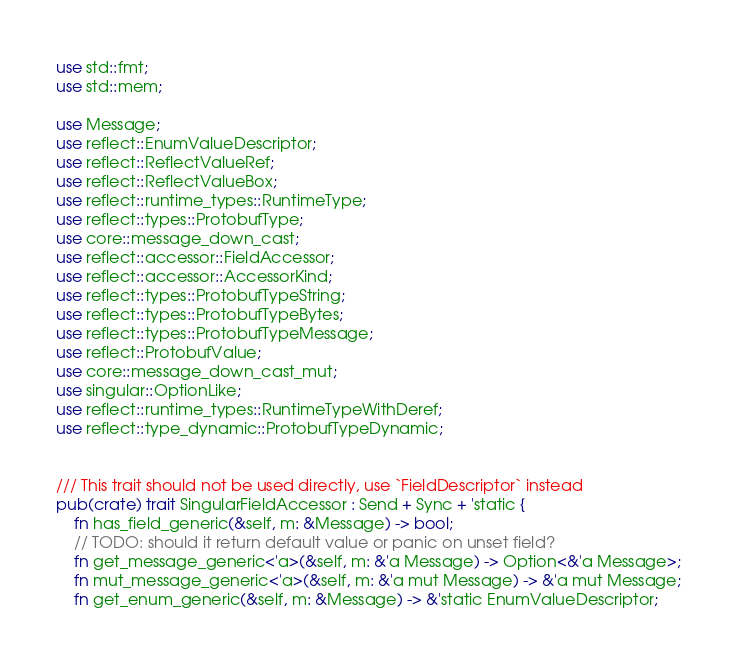<code> <loc_0><loc_0><loc_500><loc_500><_Rust_>use std::fmt;
use std::mem;

use Message;
use reflect::EnumValueDescriptor;
use reflect::ReflectValueRef;
use reflect::ReflectValueBox;
use reflect::runtime_types::RuntimeType;
use reflect::types::ProtobufType;
use core::message_down_cast;
use reflect::accessor::FieldAccessor;
use reflect::accessor::AccessorKind;
use reflect::types::ProtobufTypeString;
use reflect::types::ProtobufTypeBytes;
use reflect::types::ProtobufTypeMessage;
use reflect::ProtobufValue;
use core::message_down_cast_mut;
use singular::OptionLike;
use reflect::runtime_types::RuntimeTypeWithDeref;
use reflect::type_dynamic::ProtobufTypeDynamic;


/// This trait should not be used directly, use `FieldDescriptor` instead
pub(crate) trait SingularFieldAccessor : Send + Sync + 'static {
    fn has_field_generic(&self, m: &Message) -> bool;
    // TODO: should it return default value or panic on unset field?
    fn get_message_generic<'a>(&self, m: &'a Message) -> Option<&'a Message>;
    fn mut_message_generic<'a>(&self, m: &'a mut Message) -> &'a mut Message;
    fn get_enum_generic(&self, m: &Message) -> &'static EnumValueDescriptor;</code> 